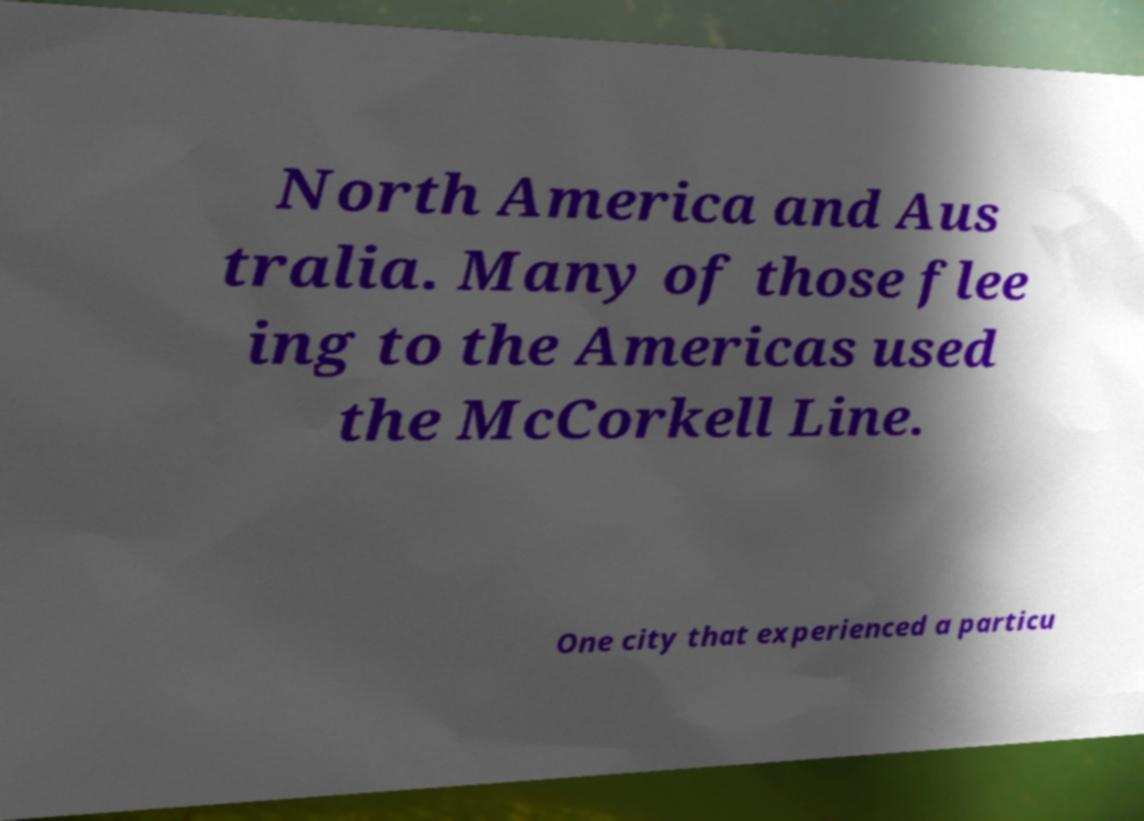There's text embedded in this image that I need extracted. Can you transcribe it verbatim? North America and Aus tralia. Many of those flee ing to the Americas used the McCorkell Line. One city that experienced a particu 